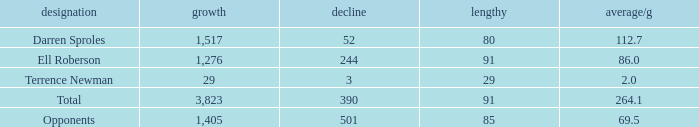What's the sum of all average yards gained when the gained yards is under 1,276 and lost more than 3 yards? None. 